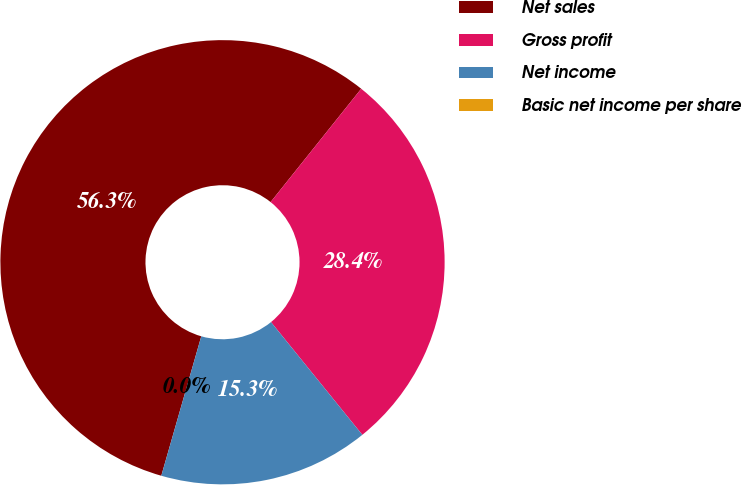Convert chart. <chart><loc_0><loc_0><loc_500><loc_500><pie_chart><fcel>Net sales<fcel>Gross profit<fcel>Net income<fcel>Basic net income per share<nl><fcel>56.29%<fcel>28.43%<fcel>15.28%<fcel>0.0%<nl></chart> 